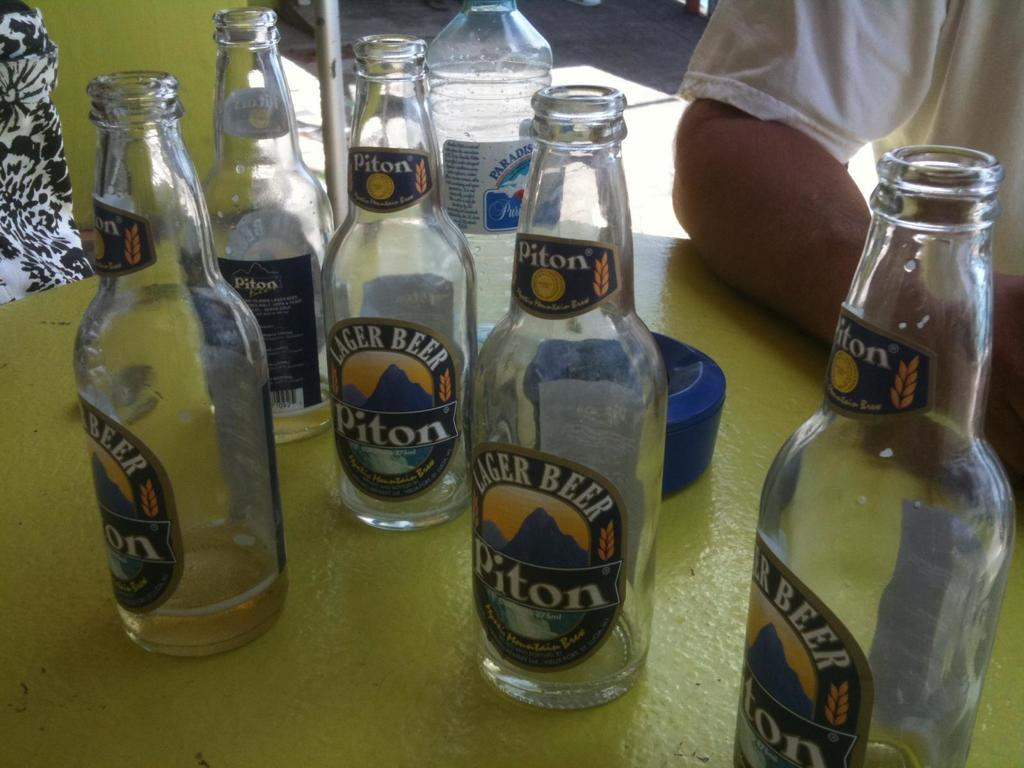What type of beverages are depicted in the image? There are beer bottles and a water bottle in the image. Where is the water bottle located in relation to the other items? The water bottle is in the center of the image. Are there any people present in the image? Yes, there is a person in the right side corner of the image. What type of quartz is visible in the image? There is no quartz present in the image. How many bubbles can be seen in the water bottle? The image does not show any bubbles in the water bottle, as it is a still image. 